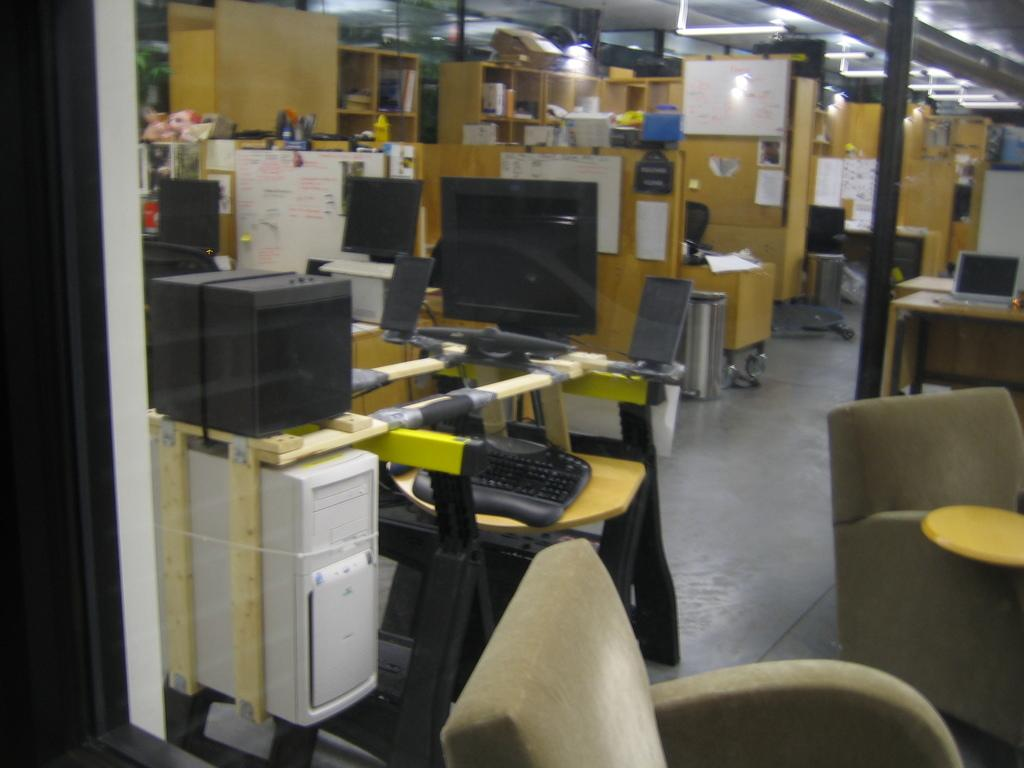What type of electronic devices are in the image? There are computers in the image. What type of furniture is in the image? There are chairs in the image. What type of stationery items are in the image? There are papers, pens, and books in the image. What type of play items are in the image? There are toys in the image. What type of storage is in the image? There is a stand and shelves in the image. What type of lighting is in the image? There are lights on top in the image. What type of orange is visible in the image? There is no orange present in the image. What part of the paper is being used in the image? There is no specific part of the paper being used in the image; the papers are simply present. 